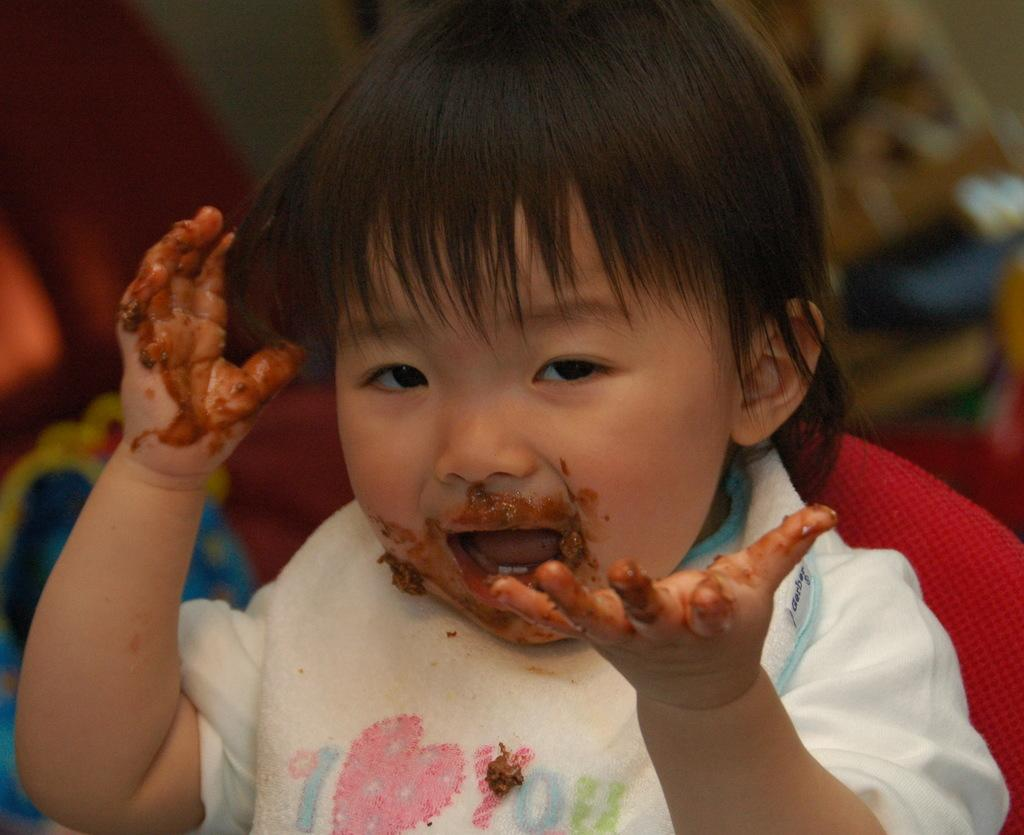Who is the main subject in the picture? There is a boy in the picture. What can be seen in the background of the image? The background of the picture contains some objects. How would you describe the quality of the image? The image is blurry. What type of punishment is the boy receiving on the island in the image? There is no island or punishment present in the image; it only features a boy and some objects in the background. 